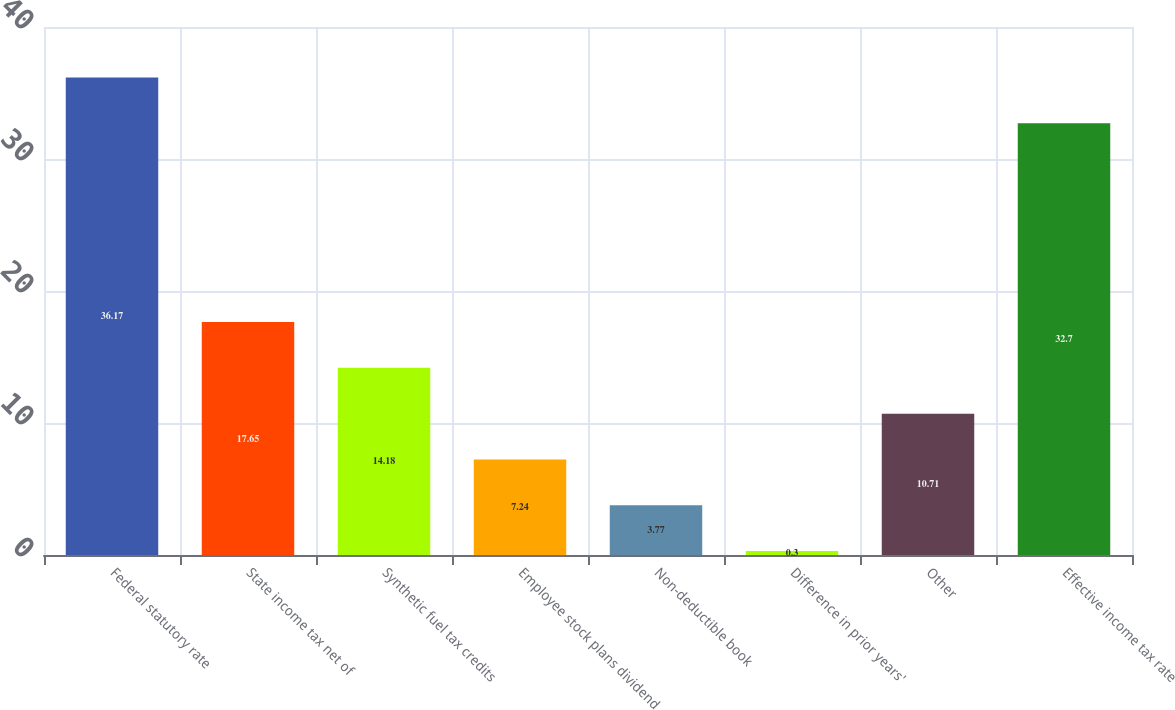Convert chart to OTSL. <chart><loc_0><loc_0><loc_500><loc_500><bar_chart><fcel>Federal statutory rate<fcel>State income tax net of<fcel>Synthetic fuel tax credits<fcel>Employee stock plans dividend<fcel>Non-deductible book<fcel>Difference in prior years'<fcel>Other<fcel>Effective income tax rate<nl><fcel>36.17<fcel>17.65<fcel>14.18<fcel>7.24<fcel>3.77<fcel>0.3<fcel>10.71<fcel>32.7<nl></chart> 